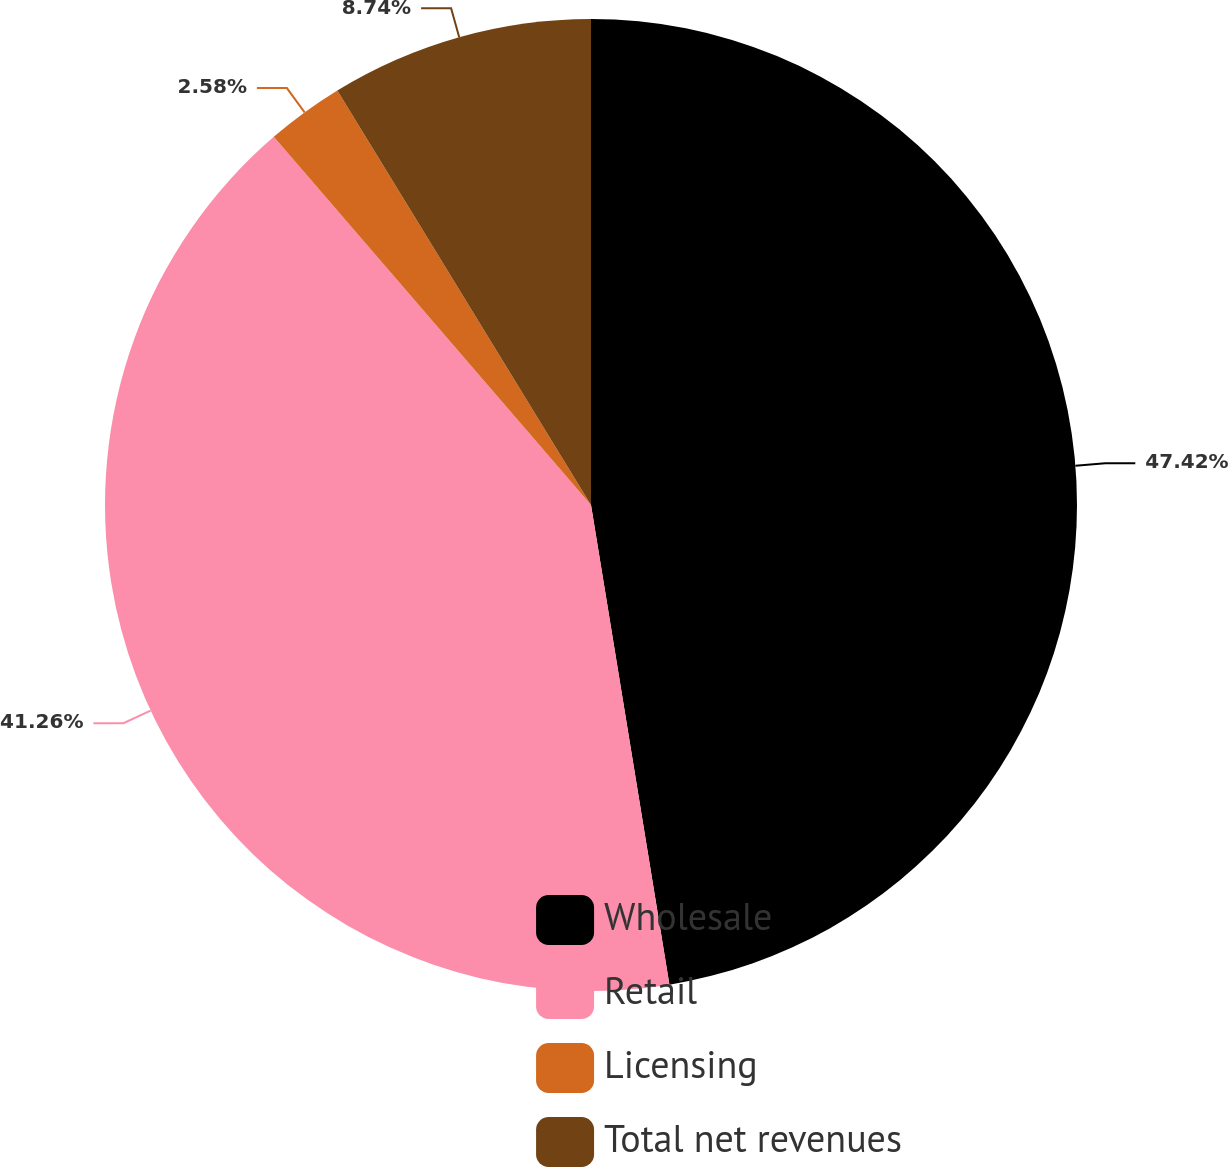Convert chart to OTSL. <chart><loc_0><loc_0><loc_500><loc_500><pie_chart><fcel>Wholesale<fcel>Retail<fcel>Licensing<fcel>Total net revenues<nl><fcel>47.42%<fcel>41.26%<fcel>2.58%<fcel>8.74%<nl></chart> 